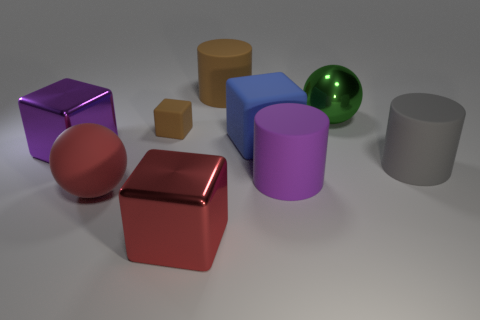Add 1 brown metal blocks. How many objects exist? 10 Subtract all cyan cylinders. Subtract all red spheres. How many cylinders are left? 3 Subtract all spheres. How many objects are left? 7 Add 7 big purple objects. How many big purple objects are left? 9 Add 2 tiny cubes. How many tiny cubes exist? 3 Subtract 0 red cylinders. How many objects are left? 9 Subtract all tiny purple metal cubes. Subtract all purple blocks. How many objects are left? 8 